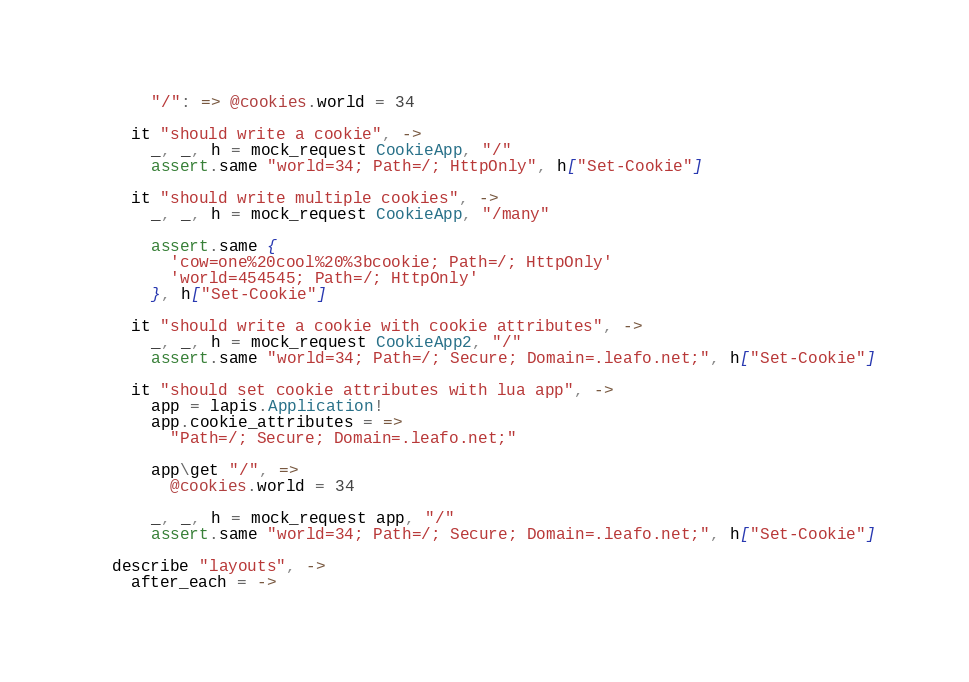Convert code to text. <code><loc_0><loc_0><loc_500><loc_500><_MoonScript_>      "/": => @cookies.world = 34

    it "should write a cookie", ->
      _, _, h = mock_request CookieApp, "/"
      assert.same "world=34; Path=/; HttpOnly", h["Set-Cookie"]

    it "should write multiple cookies", ->
      _, _, h = mock_request CookieApp, "/many"

      assert.same {
        'cow=one%20cool%20%3bcookie; Path=/; HttpOnly'
        'world=454545; Path=/; HttpOnly'
      }, h["Set-Cookie"]

    it "should write a cookie with cookie attributes", ->
      _, _, h = mock_request CookieApp2, "/"
      assert.same "world=34; Path=/; Secure; Domain=.leafo.net;", h["Set-Cookie"]

    it "should set cookie attributes with lua app", ->
      app = lapis.Application!
      app.cookie_attributes = =>
        "Path=/; Secure; Domain=.leafo.net;"

      app\get "/", =>
        @cookies.world = 34

      _, _, h = mock_request app, "/"
      assert.same "world=34; Path=/; Secure; Domain=.leafo.net;", h["Set-Cookie"]

  describe "layouts", ->
    after_each = -></code> 